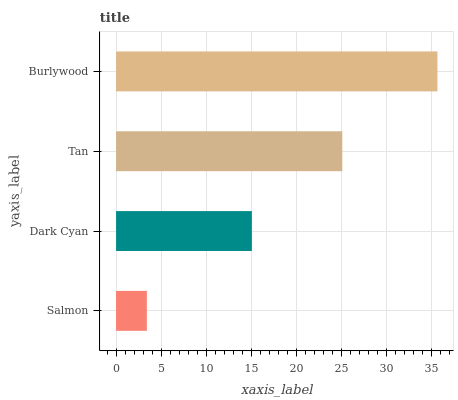Is Salmon the minimum?
Answer yes or no. Yes. Is Burlywood the maximum?
Answer yes or no. Yes. Is Dark Cyan the minimum?
Answer yes or no. No. Is Dark Cyan the maximum?
Answer yes or no. No. Is Dark Cyan greater than Salmon?
Answer yes or no. Yes. Is Salmon less than Dark Cyan?
Answer yes or no. Yes. Is Salmon greater than Dark Cyan?
Answer yes or no. No. Is Dark Cyan less than Salmon?
Answer yes or no. No. Is Tan the high median?
Answer yes or no. Yes. Is Dark Cyan the low median?
Answer yes or no. Yes. Is Dark Cyan the high median?
Answer yes or no. No. Is Tan the low median?
Answer yes or no. No. 